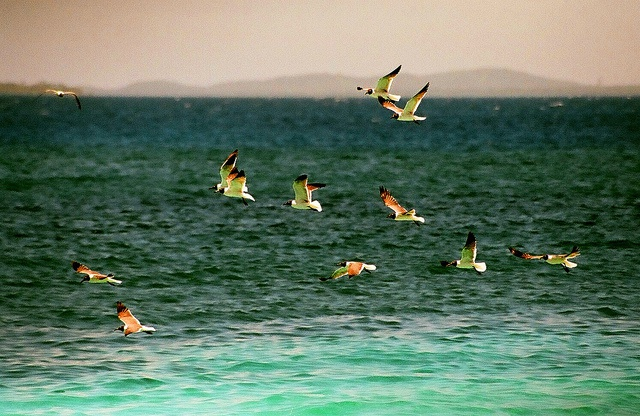Describe the objects in this image and their specific colors. I can see bird in gray, black, olive, and ivory tones, bird in gray, olive, black, ivory, and darkgreen tones, bird in gray, olive, black, ivory, and khaki tones, bird in gray, black, olive, darkgreen, and ivory tones, and bird in gray, black, orange, khaki, and ivory tones in this image. 